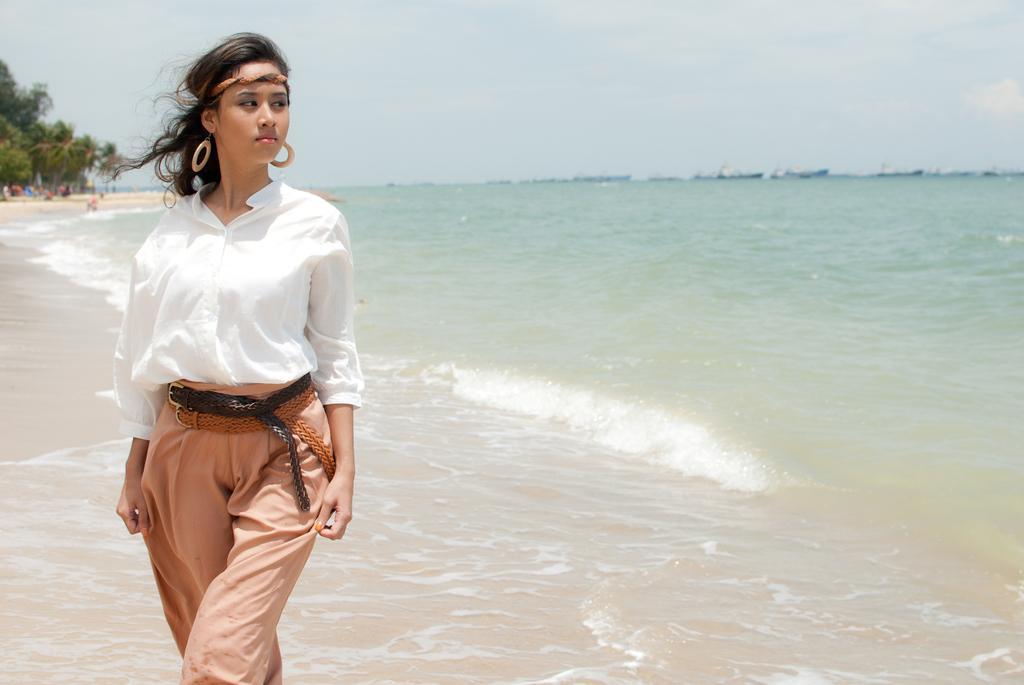Describe this image in one or two sentences. In this picture I can see there is a woman standing and she is wearing a white shirt and a pant, with belts and she is looking at right side. There is a ocean to right and there are few trees and few people into left and the sky is clear. 